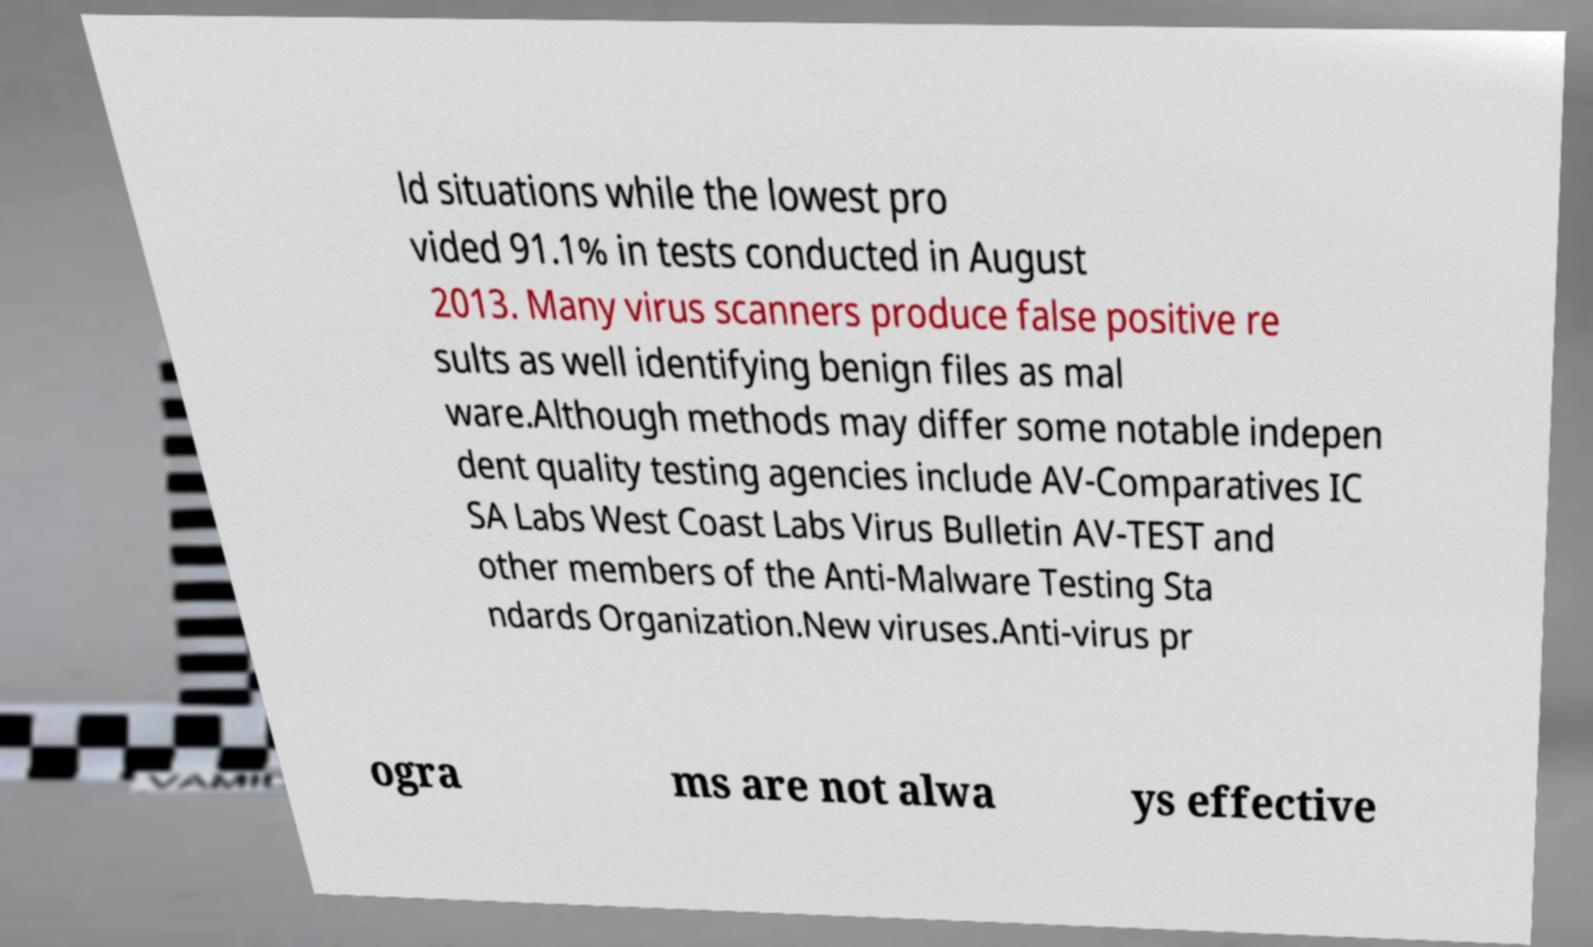Please read and relay the text visible in this image. What does it say? ld situations while the lowest pro vided 91.1% in tests conducted in August 2013. Many virus scanners produce false positive re sults as well identifying benign files as mal ware.Although methods may differ some notable indepen dent quality testing agencies include AV-Comparatives IC SA Labs West Coast Labs Virus Bulletin AV-TEST and other members of the Anti-Malware Testing Sta ndards Organization.New viruses.Anti-virus pr ogra ms are not alwa ys effective 